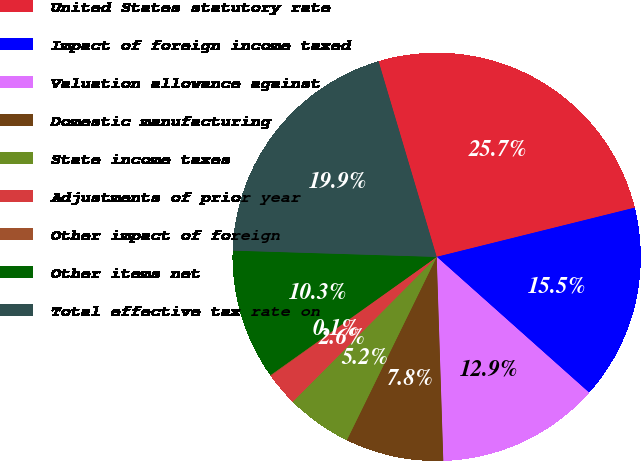<chart> <loc_0><loc_0><loc_500><loc_500><pie_chart><fcel>United States statutory rate<fcel>Impact of foreign income taxed<fcel>Valuation allowance against<fcel>Domestic manufacturing<fcel>State income taxes<fcel>Adjustments of prior year<fcel>Other impact of foreign<fcel>Other items net<fcel>Total effective tax rate on<nl><fcel>25.72%<fcel>15.46%<fcel>12.9%<fcel>7.77%<fcel>5.2%<fcel>2.64%<fcel>0.07%<fcel>10.33%<fcel>19.91%<nl></chart> 